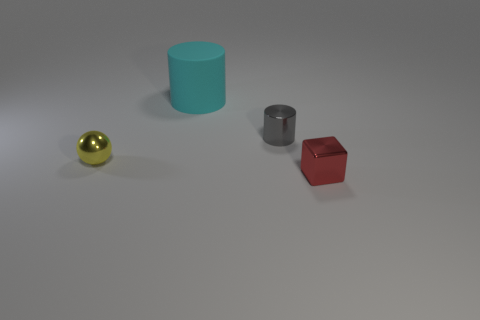Can you describe the colors and shapes of the objects seen in the image? Certainly! There are four objects in the image: a golden sphere, a blue cylinder, a gray or silver metallic cylinder, and a red cube. 